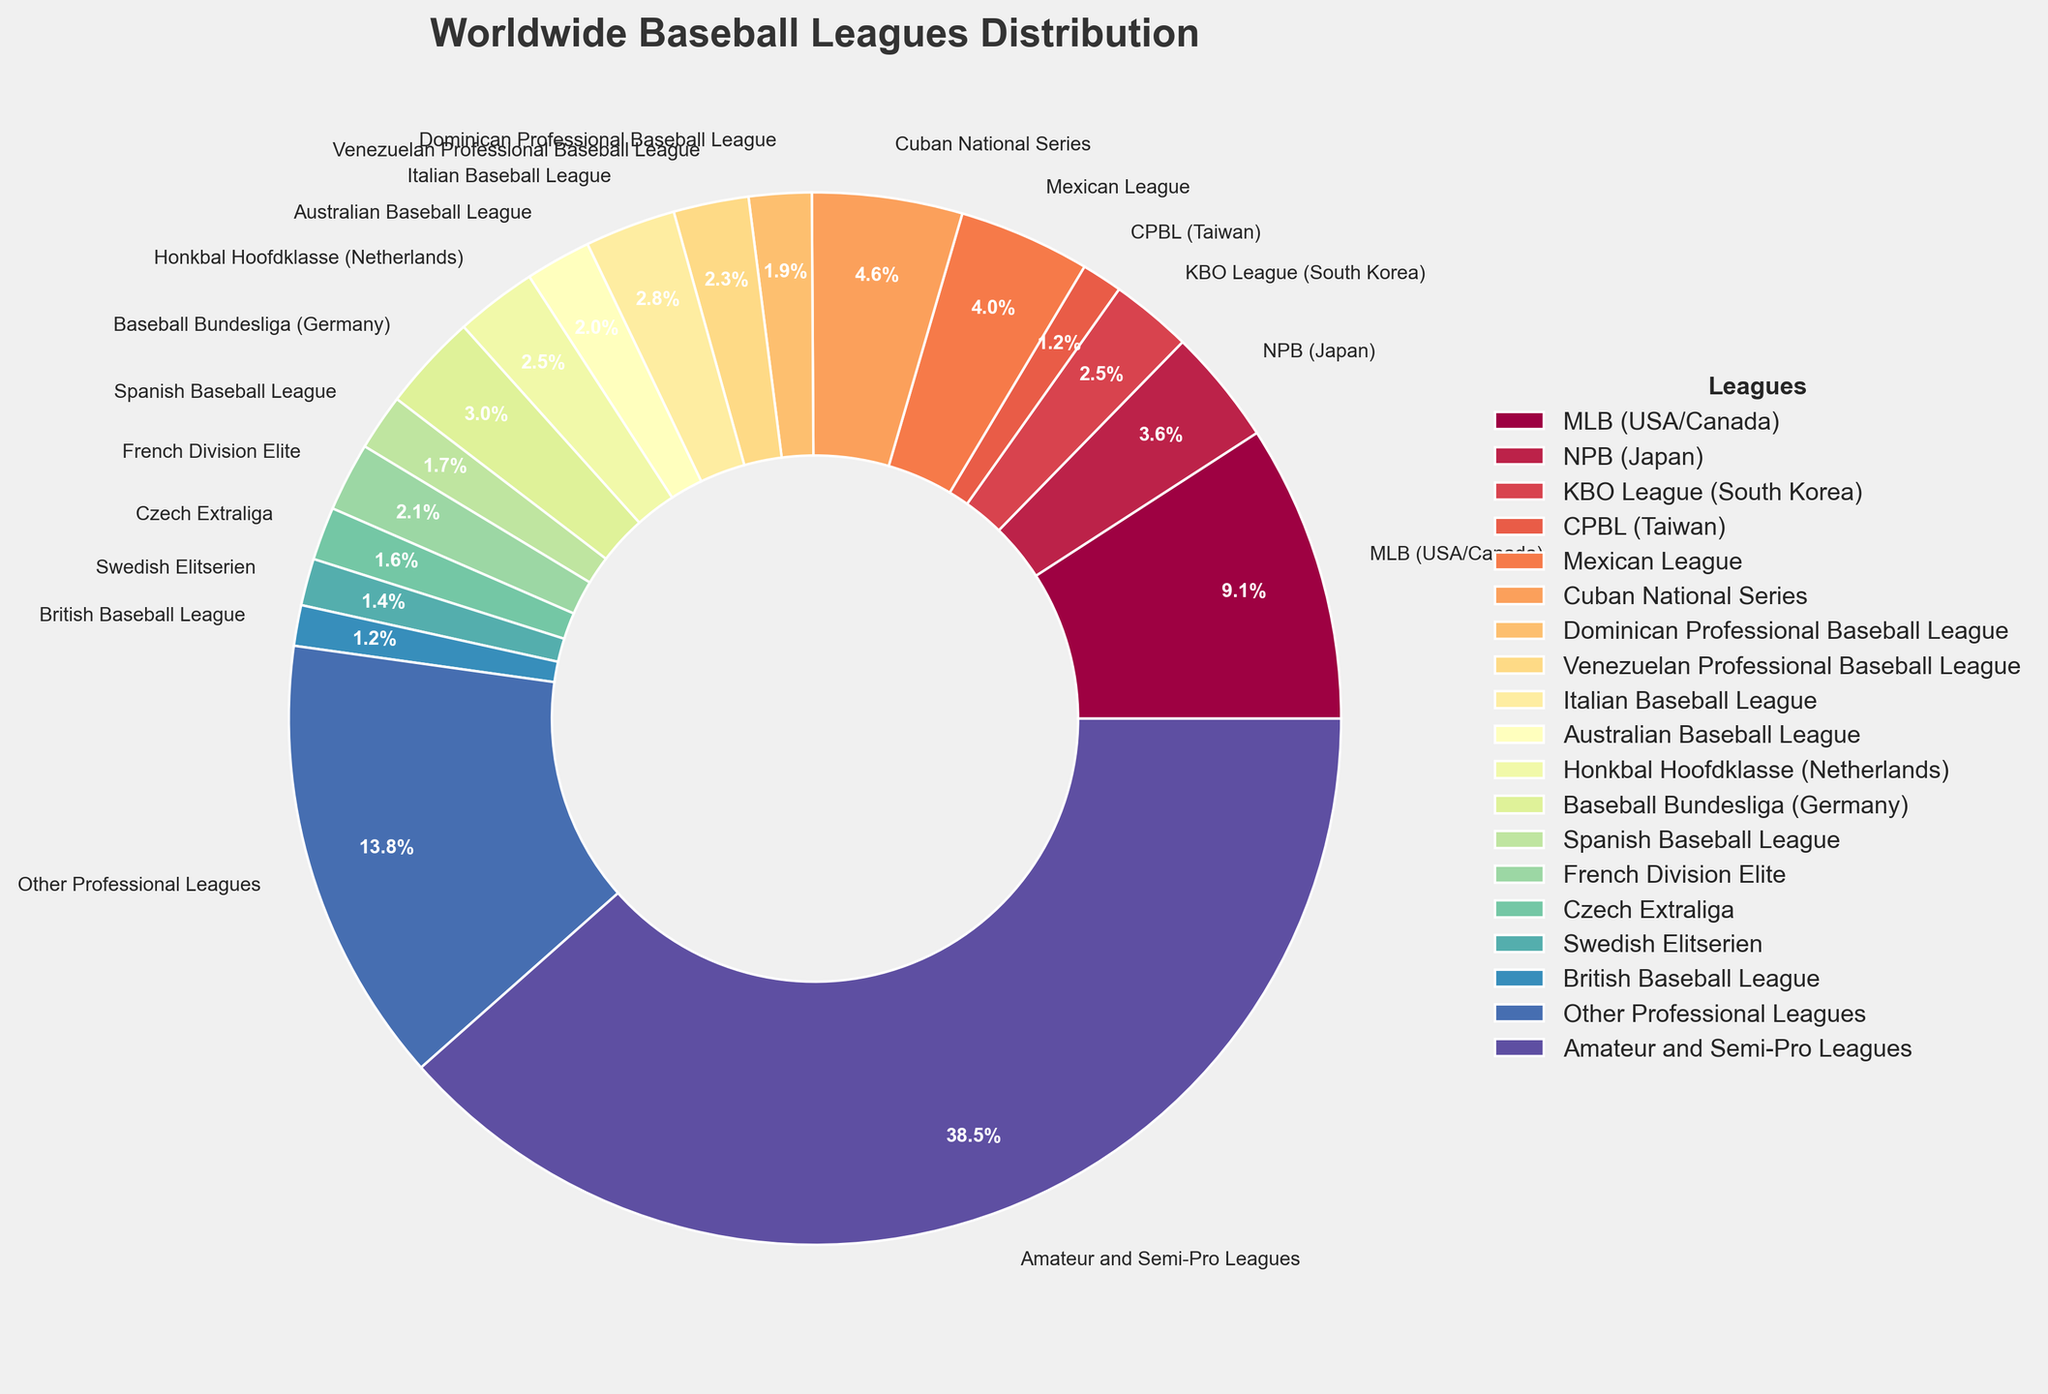What percentage of baseball teams are in the MLB? Find the segment labeled "MLB (USA/Canada)" in the pie chart, which is highlighted and labeled 9.5%.
Answer: 9.5% Which country has the second-largest percentage of baseball teams? Identify the country with the largest percentage first, which is "Amateur and Semi-Pro Leagues" at 40%, then find the next largest slice, which is "Other Professional Leagues" at 14.3%. The second-largest specific country segment is "Cuban National Series" at 4.8%.
Answer: Cuba How many more percentage points do Amateur and Semi-Pro Leagues have compared to all Asian leagues combined (NPB, KBO, and CPBL)? Sum the percentages of NPB (3.7%), KBO (2.6%), and CPBL (1.3%) to get 7.6%, then subtract it from 40%. 40% - 7.6% = 32.4%.
Answer: 32.4% Which league has the smallest percentage of baseball teams, and what is that percentage? Find the smallest segment in the pie chart, which is "British Baseball League" and "CPBL (Taiwan)" both at 1.3%.
Answer: British Baseball League and CPBL, 1.3% How does the percentage of teams in the Italian Baseball League compare to the French Division Elite? Compare the percentages for the Italian Baseball League (2.9%) and the French Division Elite (2.2%). Since 2.9% > 2.2%, the Italian Baseball League has a higher percentage.
Answer: Italian Baseball League has a higher percentage Add the percentage of teams in the Australian Baseball League to the percentage of teams in the KBO League. What is the result? Locate the Australian Baseball League (2.1%) and the KBO League (2.6%) segments, then sum them up: 2.1% + 2.6% = 4.7%.
Answer: 4.7% Which league's segment is visually next to the MLB segment in the pie chart? Examine the pie chart and note the wedges adjacent to the MLB segment, which would typically be those slightly before or after it in the clockwise direction of the plot.
Answer: The labels close to MLB will be needed (specific visual inspection required) Is the percentage of teams in Other Professional Leagues greater than the combined percentage of the Mexican League and Baseball Bundesliga? Find the respective percentages: Other Professional Leagues (14.3%), Mexican League (4.2%), and Baseball Bundesliga (3.1%). Sum the latter two percentages: 4.2% + 3.1% = 7.3%. Since 14.3% > 7.3%, yes it is greater.
Answer: Yes What is the total percentage of baseball teams found in European leagues (Italian, German, Spanish, French, Czech, Swedish, British)? Add up the percentages of the European leagues: Italian (2.9%), German (3.1%), Spanish (1.8%), French (2.2%), Czech (1.7%), Swedish (1.5%), British (1.3%). 2.9% + 3.1% + 1.8% + 2.2% + 1.7% + 1.5% + 1.3% = 14.5%.
Answer: 14.5% What visual characteristic differentiates the "Amateur and Semi-Pro Leagues" segment from most other segments in the pie chart? Observe the characteristic proportions of the segments. The "Amateur and Semi-Pro Leagues" segment is much larger in area compared to most others, making it visually distinct.
Answer: Its large size 